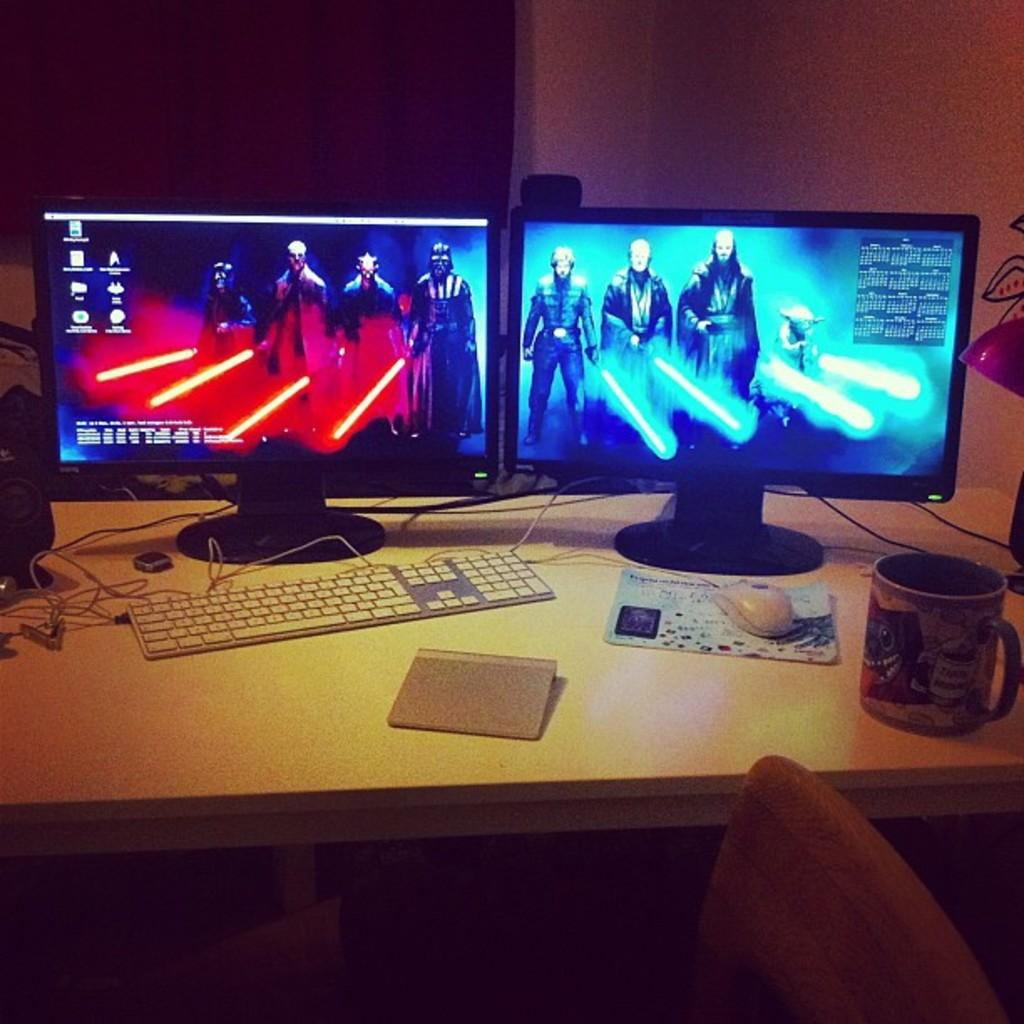What type of electronic device is on the table in the image? There is a CPU on the table in the image. What is used to interact with the CPU? There is a mouse and a keyboard on the table for interacting with the CPU. What connects the devices on the table? There are cables on the table that connect the devices. What is used to display information from the CPU? There are monitors on the table that display information from the CPU. What is in front of the table for someone to sit on? There is a chair in front of the table. What type of pan is being used to cook on the table in the image? There is no pan or cooking activity present in the image; it features a table with electronic devices. What is the opinion of the CPU on the table in the image? The image does not convey any opinions, as it is a still image of a table with electronic devices. 